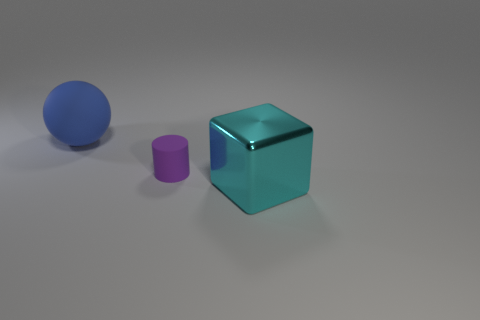What size is the matte object to the right of the large thing behind the rubber object in front of the large blue rubber thing?
Keep it short and to the point. Small. How many things are either small rubber cylinders or large yellow cubes?
Your answer should be very brief. 1. The thing that is both behind the metallic block and in front of the big rubber object has what shape?
Offer a terse response. Cylinder. There is a blue matte thing; does it have the same shape as the large object that is right of the blue rubber sphere?
Your response must be concise. No. Are there any purple rubber cylinders in front of the purple object?
Your answer should be very brief. No. How many spheres are either blue rubber objects or cyan metallic objects?
Offer a very short reply. 1. Is the shape of the metallic object the same as the purple thing?
Your response must be concise. No. What is the size of the matte thing that is to the right of the blue thing?
Make the answer very short. Small. Are there any other things that have the same color as the small thing?
Provide a succinct answer. No. There is a matte object that is in front of the rubber ball; is it the same size as the cyan cube?
Keep it short and to the point. No. 